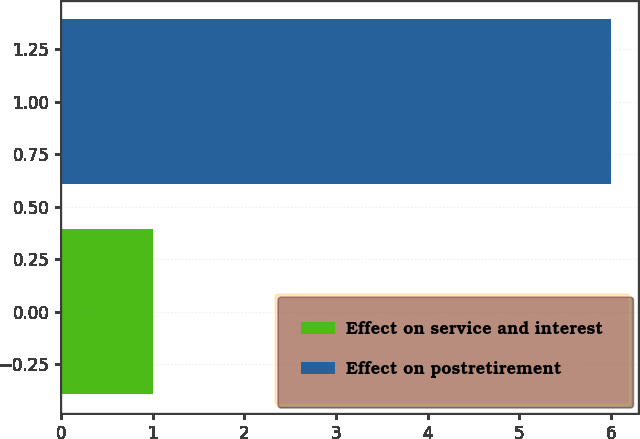Convert chart to OTSL. <chart><loc_0><loc_0><loc_500><loc_500><bar_chart><fcel>Effect on service and interest<fcel>Effect on postretirement<nl><fcel>1<fcel>6<nl></chart> 